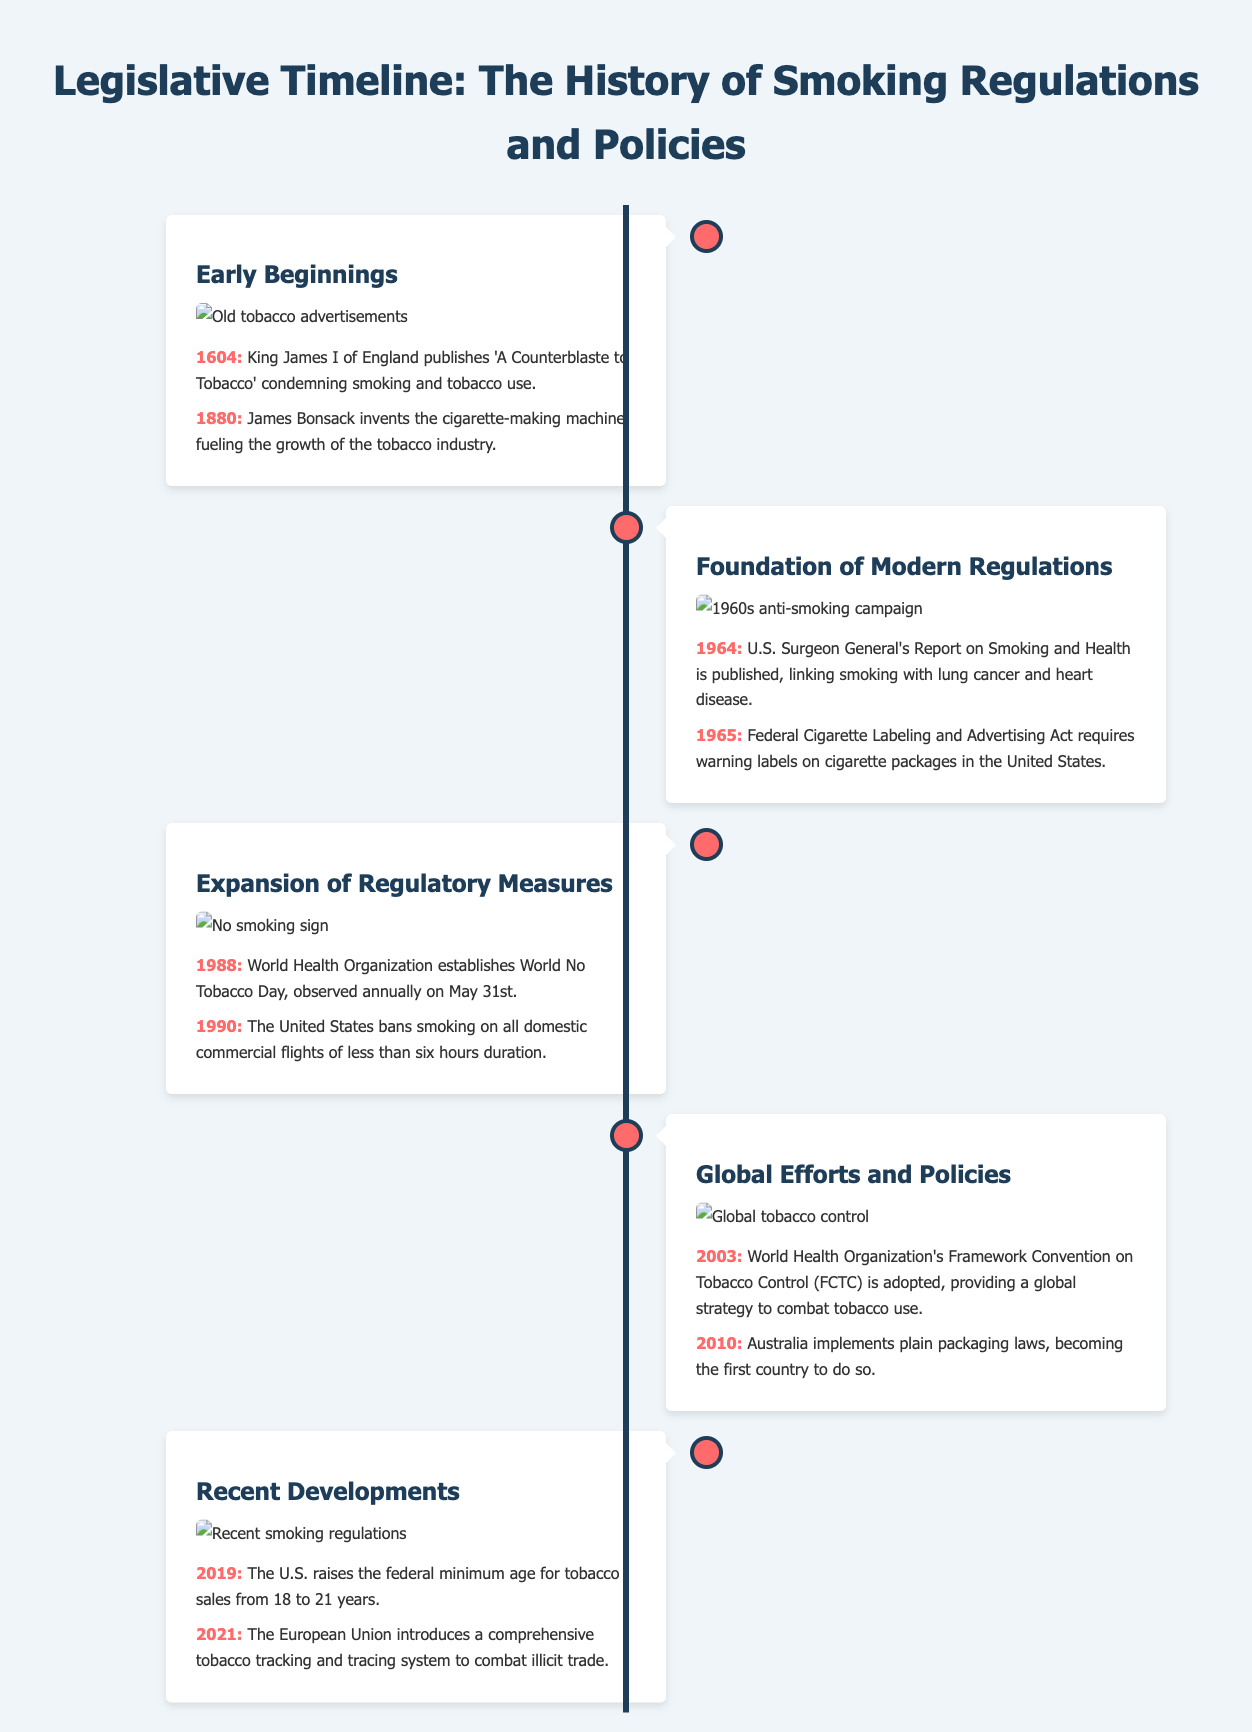What was published in 1604? The document states that in 1604, King James I of England published 'A Counterblaste to Tobacco,' condemning smoking and tobacco use.
Answer: 'A Counterblaste to Tobacco' What year was the U.S. Surgeon General's Report published? The timeline explicitly mentions that the U.S. Surgeon General's Report on Smoking and Health was published in 1964.
Answer: 1964 What does the World Health Organization establish in 1988? According to the timeline, in 1988 the World Health Organization established World No Tobacco Day, which is observed annually on May 31st.
Answer: World No Tobacco Day Which country implemented plain packaging laws in 2010? The document states that Australia implemented plain packaging laws in 2010, becoming the first country to do so.
Answer: Australia What is the significance of the year 2003? In 2003, the World Health Organization's Framework Convention on Tobacco Control was adopted, providing a global strategy to combat tobacco use.
Answer: FCTC What are the key features of the document format? The document features a timeline with sections divided into milestones and images, showcasing important dates and events related to smoking regulations.
Answer: Timeline with milestones and images What is the maximum width of the container in the document? The maximum width of the container for the document is defined as 1200px, as per the styling mentioned.
Answer: 1200px What major change occurred in the U.S. in 2019? In 2019, the U.S. raised the federal minimum age for tobacco sales from 18 to 21 years, indicating a significant regulatory change.
Answer: 21 years 